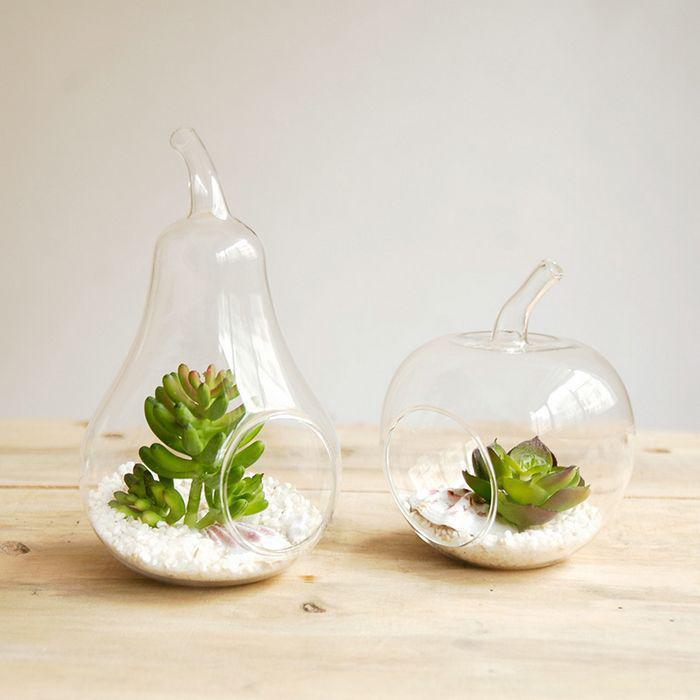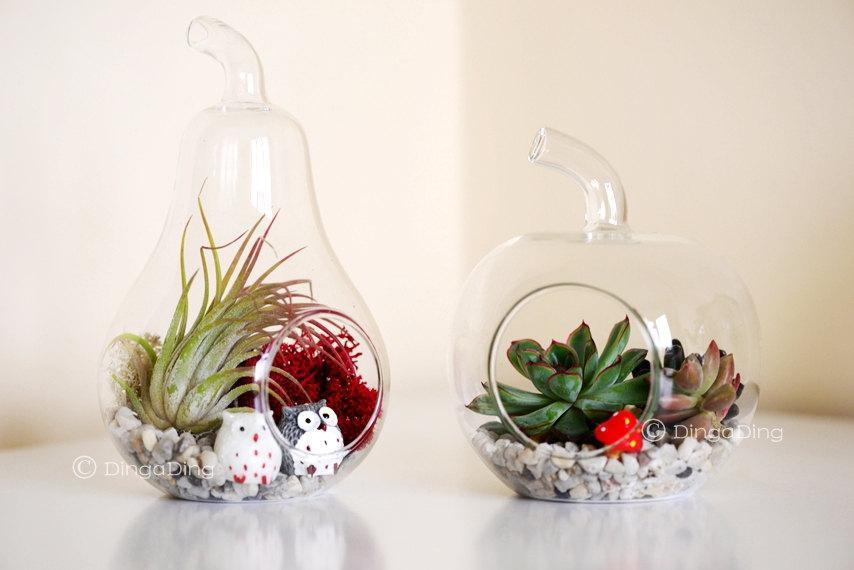The first image is the image on the left, the second image is the image on the right. Given the left and right images, does the statement "Each image contains side-by-side terrariums in fruit shapes that rest on a surface, and the combined images include at least two pear shapes and one apple shape." hold true? Answer yes or no. Yes. The first image is the image on the left, the second image is the image on the right. Evaluate the accuracy of this statement regarding the images: "A single terrarium shaped like a pear sits on a surface in the image on the left.". Is it true? Answer yes or no. No. 